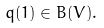Convert formula to latex. <formula><loc_0><loc_0><loc_500><loc_500>q ( 1 ) \in B ( V ) .</formula> 